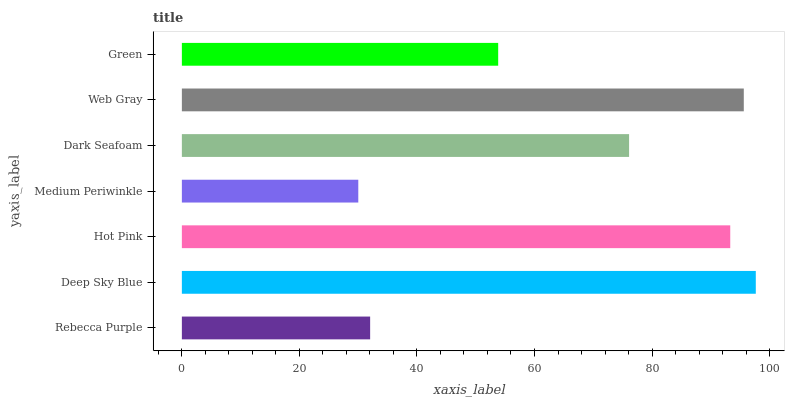Is Medium Periwinkle the minimum?
Answer yes or no. Yes. Is Deep Sky Blue the maximum?
Answer yes or no. Yes. Is Hot Pink the minimum?
Answer yes or no. No. Is Hot Pink the maximum?
Answer yes or no. No. Is Deep Sky Blue greater than Hot Pink?
Answer yes or no. Yes. Is Hot Pink less than Deep Sky Blue?
Answer yes or no. Yes. Is Hot Pink greater than Deep Sky Blue?
Answer yes or no. No. Is Deep Sky Blue less than Hot Pink?
Answer yes or no. No. Is Dark Seafoam the high median?
Answer yes or no. Yes. Is Dark Seafoam the low median?
Answer yes or no. Yes. Is Medium Periwinkle the high median?
Answer yes or no. No. Is Web Gray the low median?
Answer yes or no. No. 